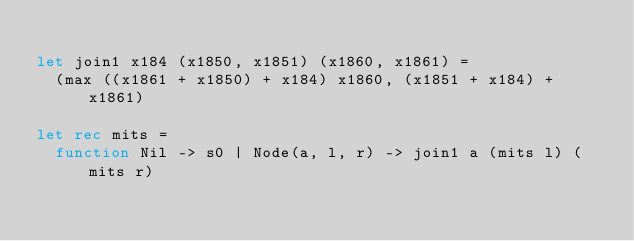Convert code to text. <code><loc_0><loc_0><loc_500><loc_500><_OCaml_>
let join1 x184 (x1850, x1851) (x1860, x1861) =
  (max ((x1861 + x1850) + x184) x1860, (x1851 + x184) + x1861)

let rec mits =
  function Nil -> s0 | Node(a, l, r) -> join1 a (mits l) (mits r)

</code> 